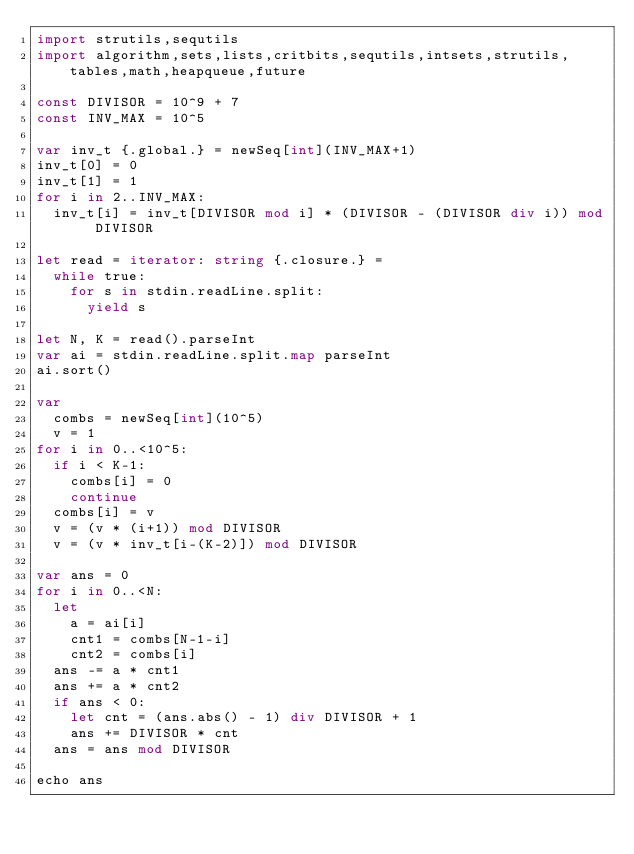Convert code to text. <code><loc_0><loc_0><loc_500><loc_500><_Nim_>import strutils,sequtils
import algorithm,sets,lists,critbits,sequtils,intsets,strutils,tables,math,heapqueue,future

const DIVISOR = 10^9 + 7
const INV_MAX = 10^5

var inv_t {.global.} = newSeq[int](INV_MAX+1)
inv_t[0] = 0
inv_t[1] = 1
for i in 2..INV_MAX:
  inv_t[i] = inv_t[DIVISOR mod i] * (DIVISOR - (DIVISOR div i)) mod DIVISOR

let read = iterator: string {.closure.} =
  while true:
    for s in stdin.readLine.split:
      yield s

let N, K = read().parseInt
var ai = stdin.readLine.split.map parseInt
ai.sort()

var
  combs = newSeq[int](10^5)
  v = 1
for i in 0..<10^5:
  if i < K-1:
    combs[i] = 0
    continue
  combs[i] = v
  v = (v * (i+1)) mod DIVISOR
  v = (v * inv_t[i-(K-2)]) mod DIVISOR

var ans = 0
for i in 0..<N:
  let
    a = ai[i]
    cnt1 = combs[N-1-i]
    cnt2 = combs[i]
  ans -= a * cnt1
  ans += a * cnt2
  if ans < 0:
    let cnt = (ans.abs() - 1) div DIVISOR + 1
    ans += DIVISOR * cnt
  ans = ans mod DIVISOR

echo ans
</code> 